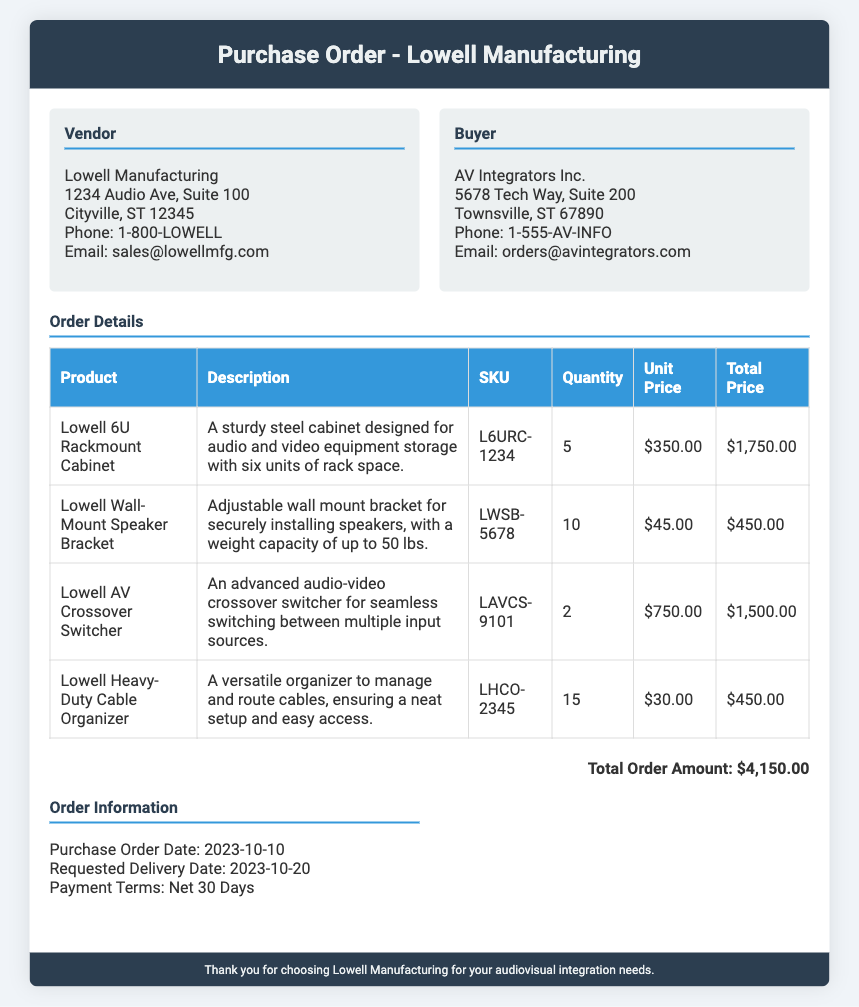What is the purchase order date? The purchase order date is mentioned in the document as the date the order was created.
Answer: 2023-10-10 What is the total order amount? The total order amount is summarized at the end of the order details section.
Answer: $4,150.00 How many Lowell Wall-Mount Speaker Brackets were ordered? The quantity of Lowell Wall-Mount Speaker Brackets can be found in the order details table.
Answer: 10 What is the SKU for the Lowell 6U Rackmount Cabinet? The SKU is listed in the order details alongside the product description.
Answer: L6URC-1234 What are the payment terms specified in the document? The payment terms are included in the order information section.
Answer: Net 30 Days What product has the highest unit price? To determine this, one must compare the unit prices listed in the order details section.
Answer: Lowell AV Crossover Switcher How many total products are listed in the order? This is acquired by counting the number of product entries in the order details table.
Answer: 4 What is the requested delivery date? The requested delivery date is found in the order information section.
Answer: 2023-10-20 What is the weight capacity of the Lowell Wall-Mount Speaker Bracket? This information is included in the description of the product in the order details.
Answer: Up to 50 lbs 